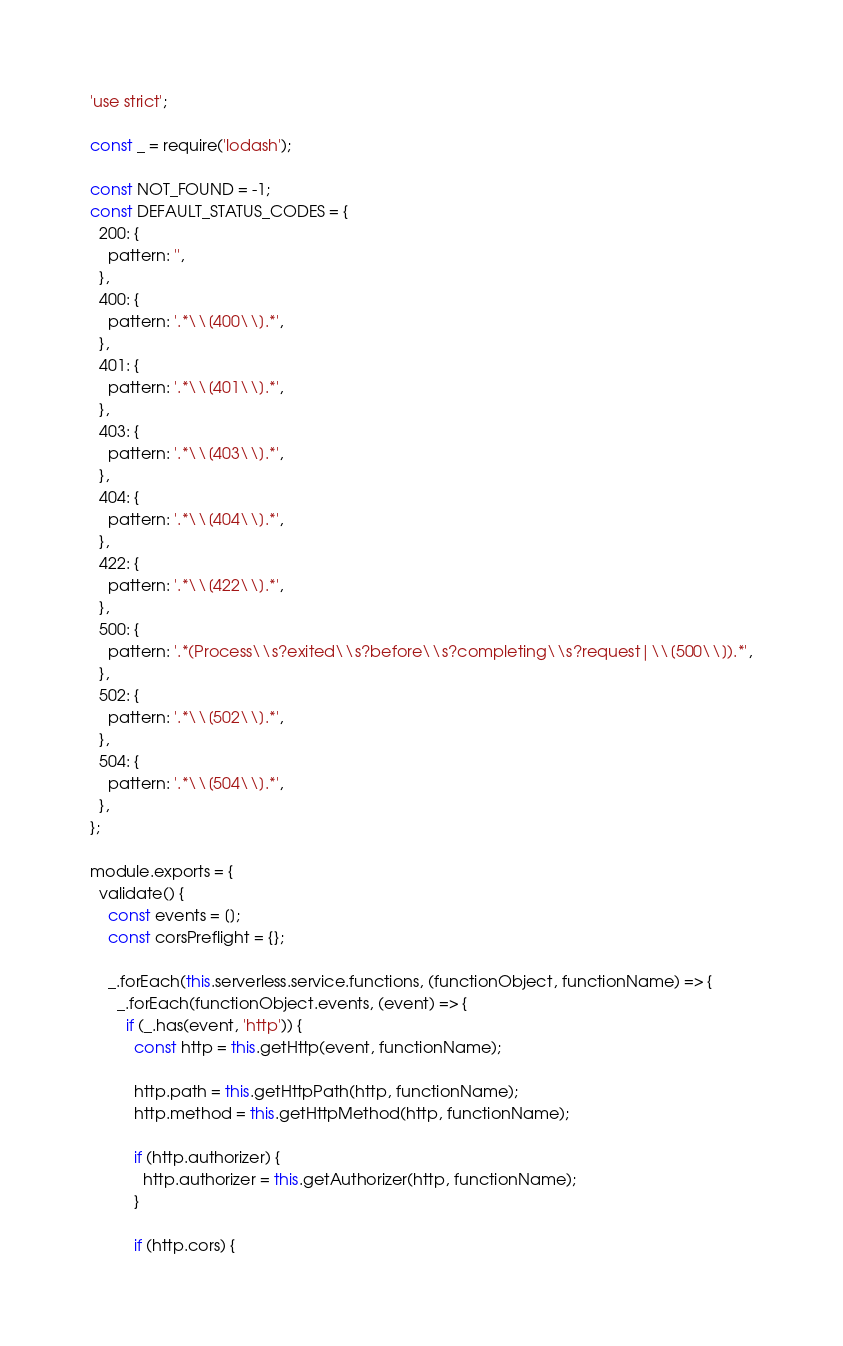Convert code to text. <code><loc_0><loc_0><loc_500><loc_500><_JavaScript_>'use strict';

const _ = require('lodash');

const NOT_FOUND = -1;
const DEFAULT_STATUS_CODES = {
  200: {
    pattern: '',
  },
  400: {
    pattern: '.*\\[400\\].*',
  },
  401: {
    pattern: '.*\\[401\\].*',
  },
  403: {
    pattern: '.*\\[403\\].*',
  },
  404: {
    pattern: '.*\\[404\\].*',
  },
  422: {
    pattern: '.*\\[422\\].*',
  },
  500: {
    pattern: '.*(Process\\s?exited\\s?before\\s?completing\\s?request|\\[500\\]).*',
  },
  502: {
    pattern: '.*\\[502\\].*',
  },
  504: {
    pattern: '.*\\[504\\].*',
  },
};

module.exports = {
  validate() {
    const events = [];
    const corsPreflight = {};

    _.forEach(this.serverless.service.functions, (functionObject, functionName) => {
      _.forEach(functionObject.events, (event) => {
        if (_.has(event, 'http')) {
          const http = this.getHttp(event, functionName);

          http.path = this.getHttpPath(http, functionName);
          http.method = this.getHttpMethod(http, functionName);

          if (http.authorizer) {
            http.authorizer = this.getAuthorizer(http, functionName);
          }

          if (http.cors) {</code> 